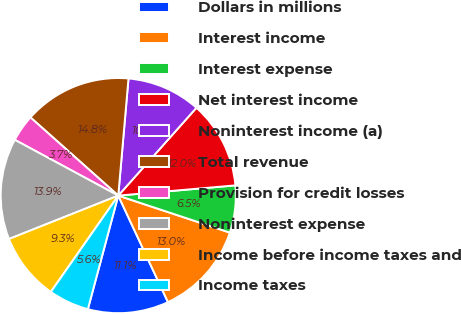<chart> <loc_0><loc_0><loc_500><loc_500><pie_chart><fcel>Dollars in millions<fcel>Interest income<fcel>Interest expense<fcel>Net interest income<fcel>Noninterest income (a)<fcel>Total revenue<fcel>Provision for credit losses<fcel>Noninterest expense<fcel>Income before income taxes and<fcel>Income taxes<nl><fcel>11.11%<fcel>12.96%<fcel>6.48%<fcel>12.04%<fcel>10.19%<fcel>14.81%<fcel>3.71%<fcel>13.89%<fcel>9.26%<fcel>5.56%<nl></chart> 